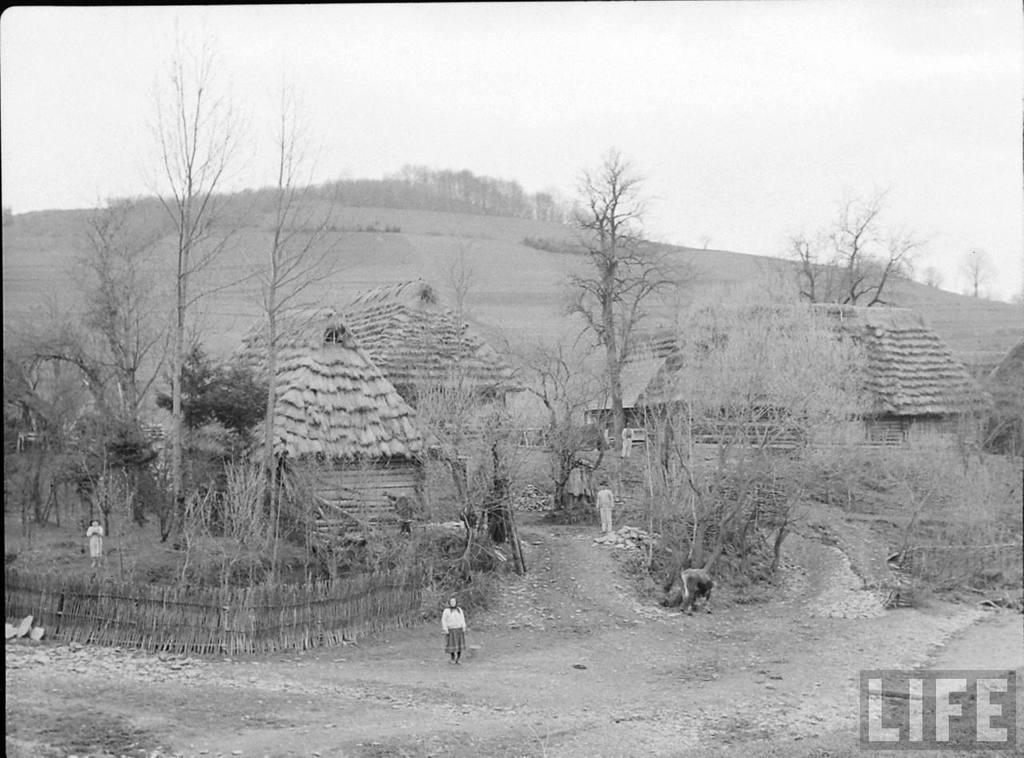Describe this image in one or two sentences. In this picture I can see houses, trees and people are standing on the ground. In the background I can see the sky. This picture is black and white in color. Here I can see a watermark. 